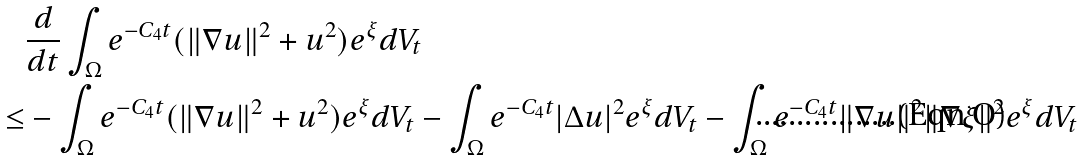Convert formula to latex. <formula><loc_0><loc_0><loc_500><loc_500>& \frac { d } { d t } \int _ { \Omega } e ^ { - C _ { 4 } t } ( \| \nabla u \| ^ { 2 } + u ^ { 2 } ) e ^ { \xi } d V _ { t } \\ \leq & - \int _ { \Omega } e ^ { - C _ { 4 } t } ( \| \nabla u \| ^ { 2 } + u ^ { 2 } ) e ^ { \xi } d V _ { t } - \int _ { \Omega } e ^ { - C _ { 4 } t } | \Delta u | ^ { 2 } e ^ { \xi } d V _ { t } - \int _ { \Omega } e ^ { - C _ { 4 } t } \| \nabla u \| ^ { 2 } \| \nabla \xi \| ^ { 2 } e ^ { \xi } d V _ { t }</formula> 